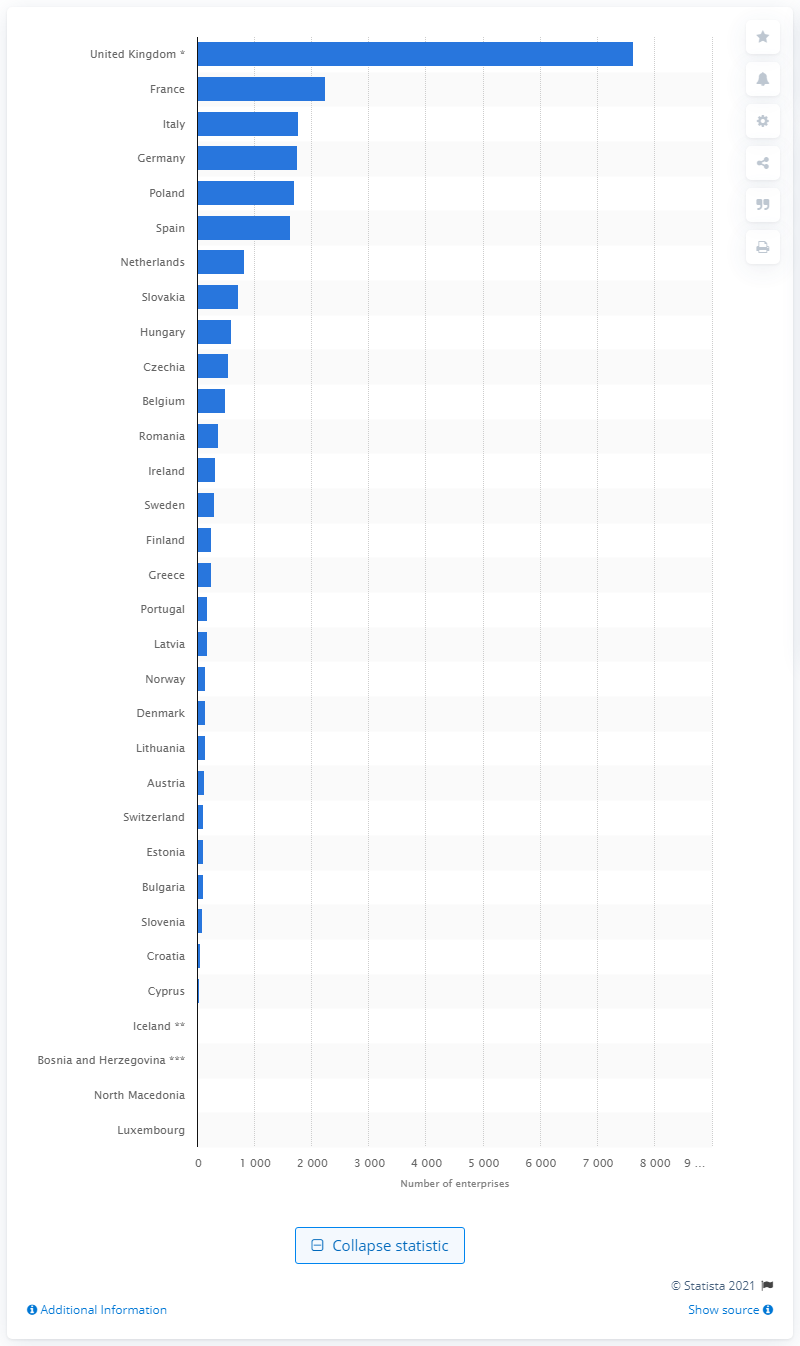Specify some key components in this picture. In 2016, there were approximately 7,630 enterprises operating in the warehouse and storage industry in the United Kingdom. 